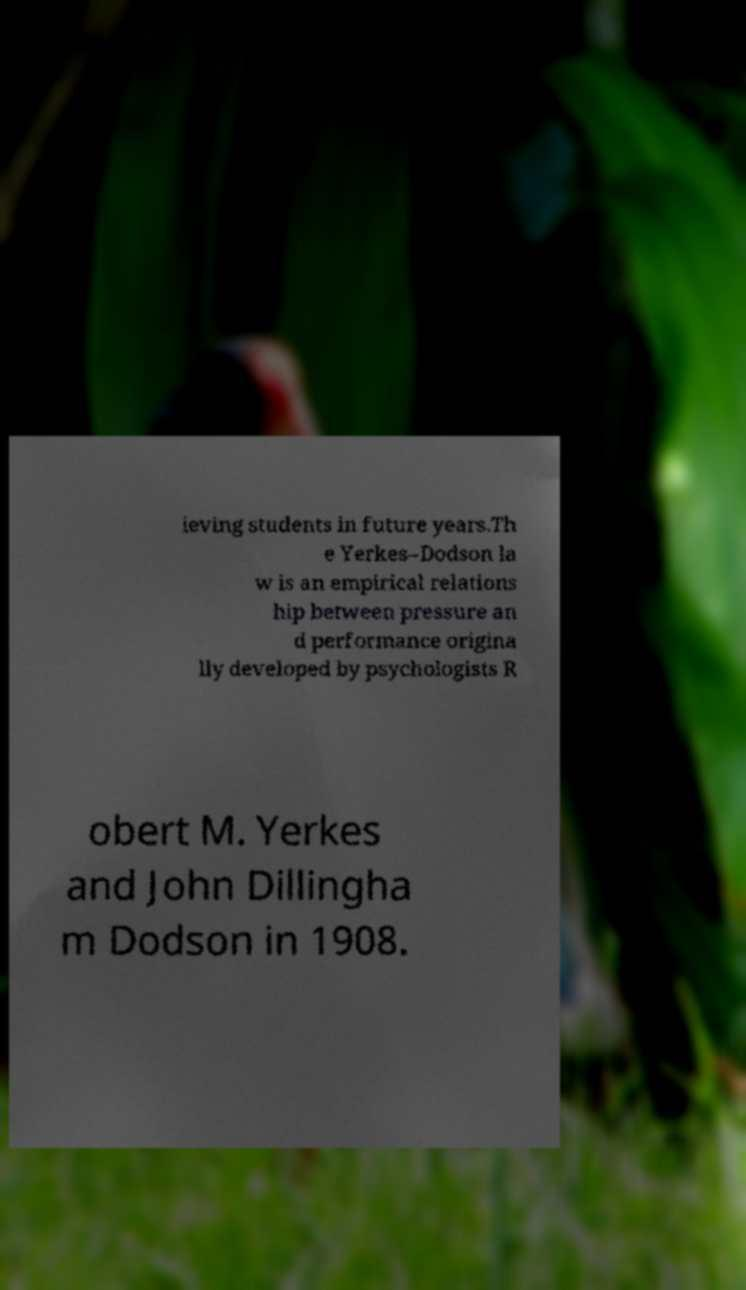For documentation purposes, I need the text within this image transcribed. Could you provide that? ieving students in future years.Th e Yerkes–Dodson la w is an empirical relations hip between pressure an d performance origina lly developed by psychologists R obert M. Yerkes and John Dillingha m Dodson in 1908. 